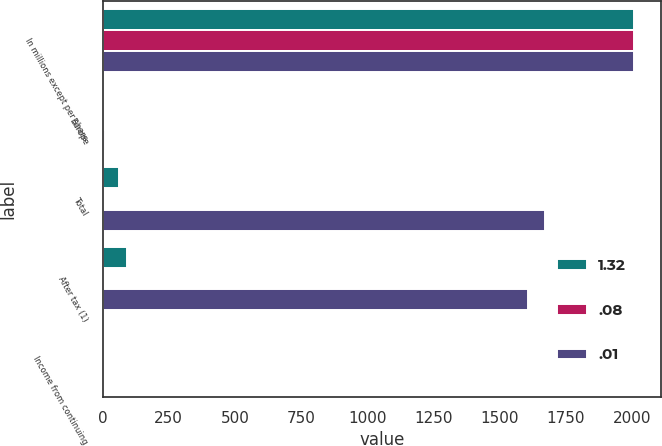<chart> <loc_0><loc_0><loc_500><loc_500><stacked_bar_chart><ecel><fcel>In millions except per share<fcel>Europe<fcel>Total<fcel>After tax (1)<fcel>Income from continuing<nl><fcel>1.32<fcel>2009<fcel>4<fcel>61<fcel>91<fcel>0.08<nl><fcel>0.08<fcel>2008<fcel>6<fcel>6<fcel>4<fcel>0.01<nl><fcel>0.01<fcel>2007<fcel>11<fcel>1670<fcel>1606<fcel>1.32<nl></chart> 